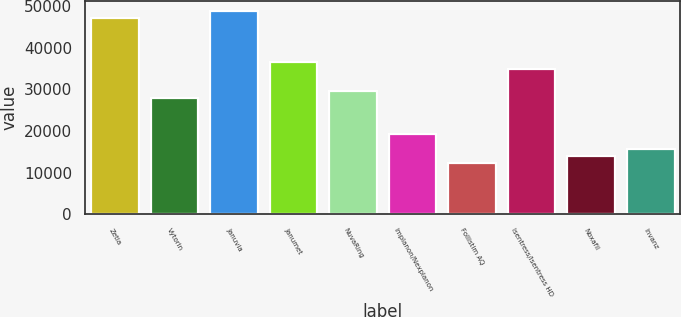Convert chart to OTSL. <chart><loc_0><loc_0><loc_500><loc_500><bar_chart><fcel>Zetia<fcel>Vytorin<fcel>Januvia<fcel>Janumet<fcel>NuvaRing<fcel>Implanon/Nexplanon<fcel>Follistim AQ<fcel>Isentress/Isentress HD<fcel>Noxafil<fcel>Invanz<nl><fcel>47105.8<fcel>27917.4<fcel>48850.2<fcel>36639.4<fcel>29661.8<fcel>19195.4<fcel>12217.8<fcel>34895<fcel>13962.2<fcel>15706.6<nl></chart> 